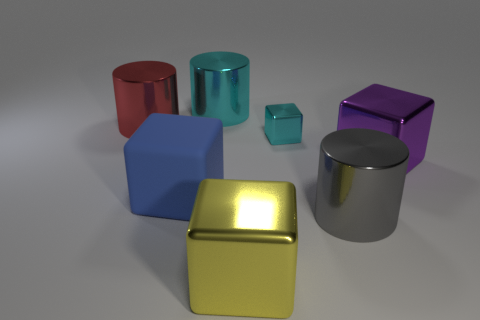Add 1 large yellow shiny things. How many objects exist? 8 Subtract all cubes. How many objects are left? 3 Add 6 tiny cyan cubes. How many tiny cyan cubes exist? 7 Subtract 1 blue cubes. How many objects are left? 6 Subtract all blue rubber objects. Subtract all cyan metallic objects. How many objects are left? 4 Add 2 big yellow metallic things. How many big yellow metallic things are left? 3 